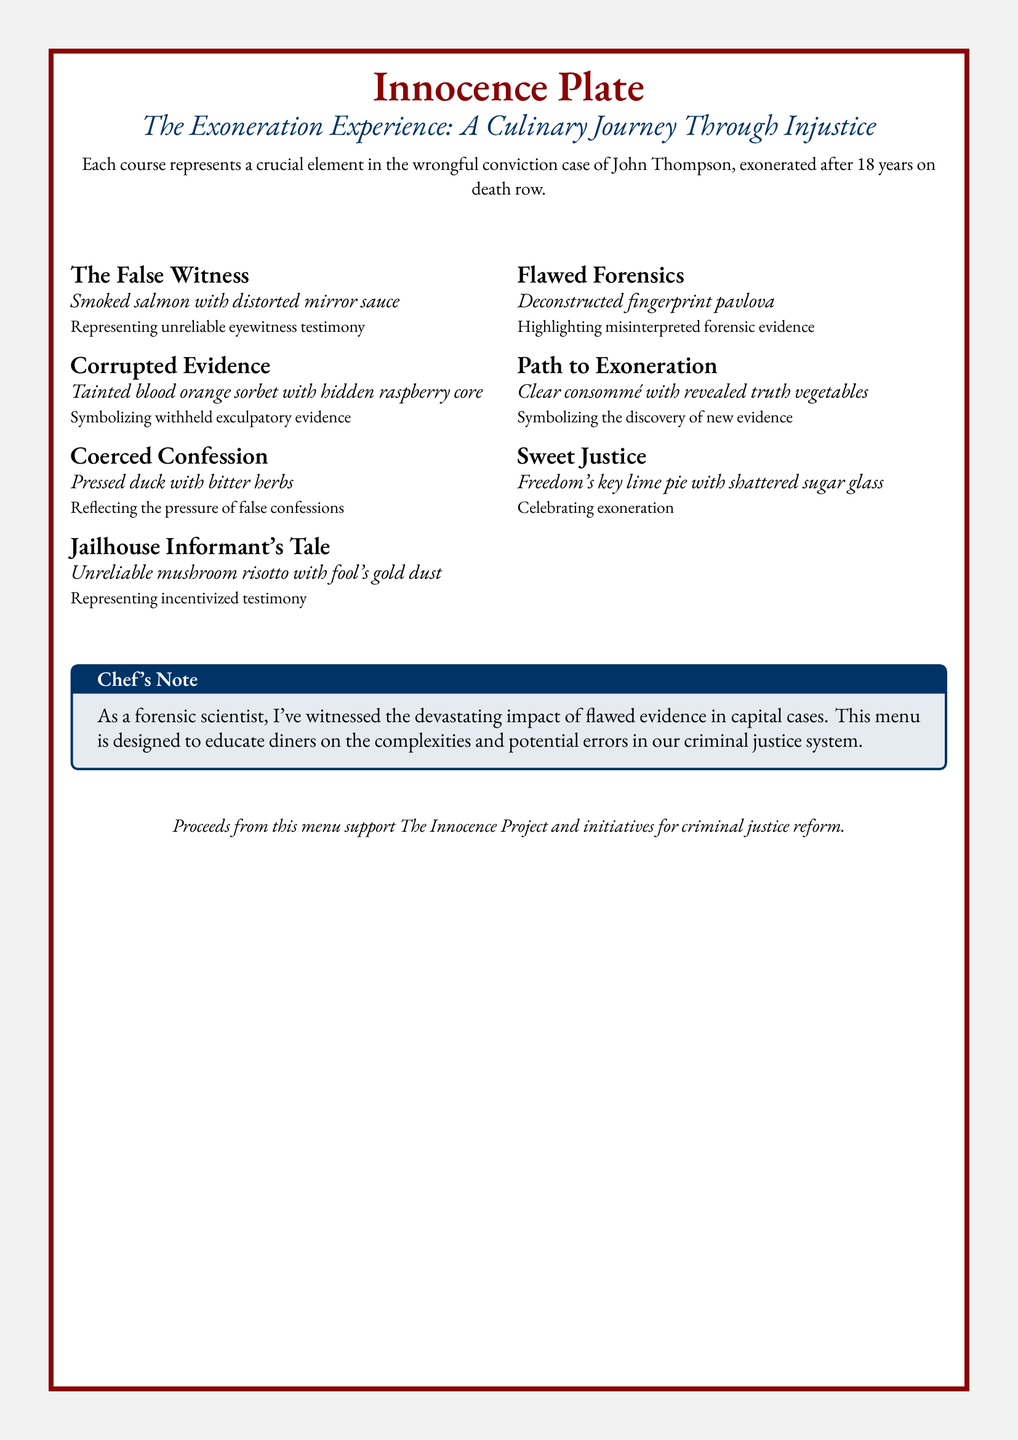What is the title of the menu? The title is found at the top of the document and summarizes the theme of the experience.
Answer: Innocence Plate How many courses are included in the tasting menu? The courses can be counted from the list presented in the menu, revealing the total offerings.
Answer: Seven What does the "False Witness" course represent? This information is directly stated beneath the course title, providing context for its significance in the wrongful conviction case.
Answer: Unreliable eyewitness testimony What color is the frame of the tcolorbox? The color can be identified from the document's color specifications, indicating its visual design element.
Answer: Bloodred Which course symbolizes the discovery of new evidence? This course can be identified by matching its description to the corresponding course in the menu.
Answer: Path to Exoneration What key ingredient is featured in the "Sweet Justice" course? The key ingredient is explicitly mentioned in the course description, highlighting its significance.
Answer: Key lime What is the purpose of proceeds from this menu? This information is located at the bottom of the document, outlining the menu's social implication.
Answer: Support The Innocence Project What culinary technique is used in the "Flawed Forensics" course? This detail is given in the course description and relates to the overall theme of misinterpretation.
Answer: Deconstructed Which color represents justice in the menu? The color is associated with the theme of justice throughout the menu and is visually identifiable.
Answer: Justice blue 